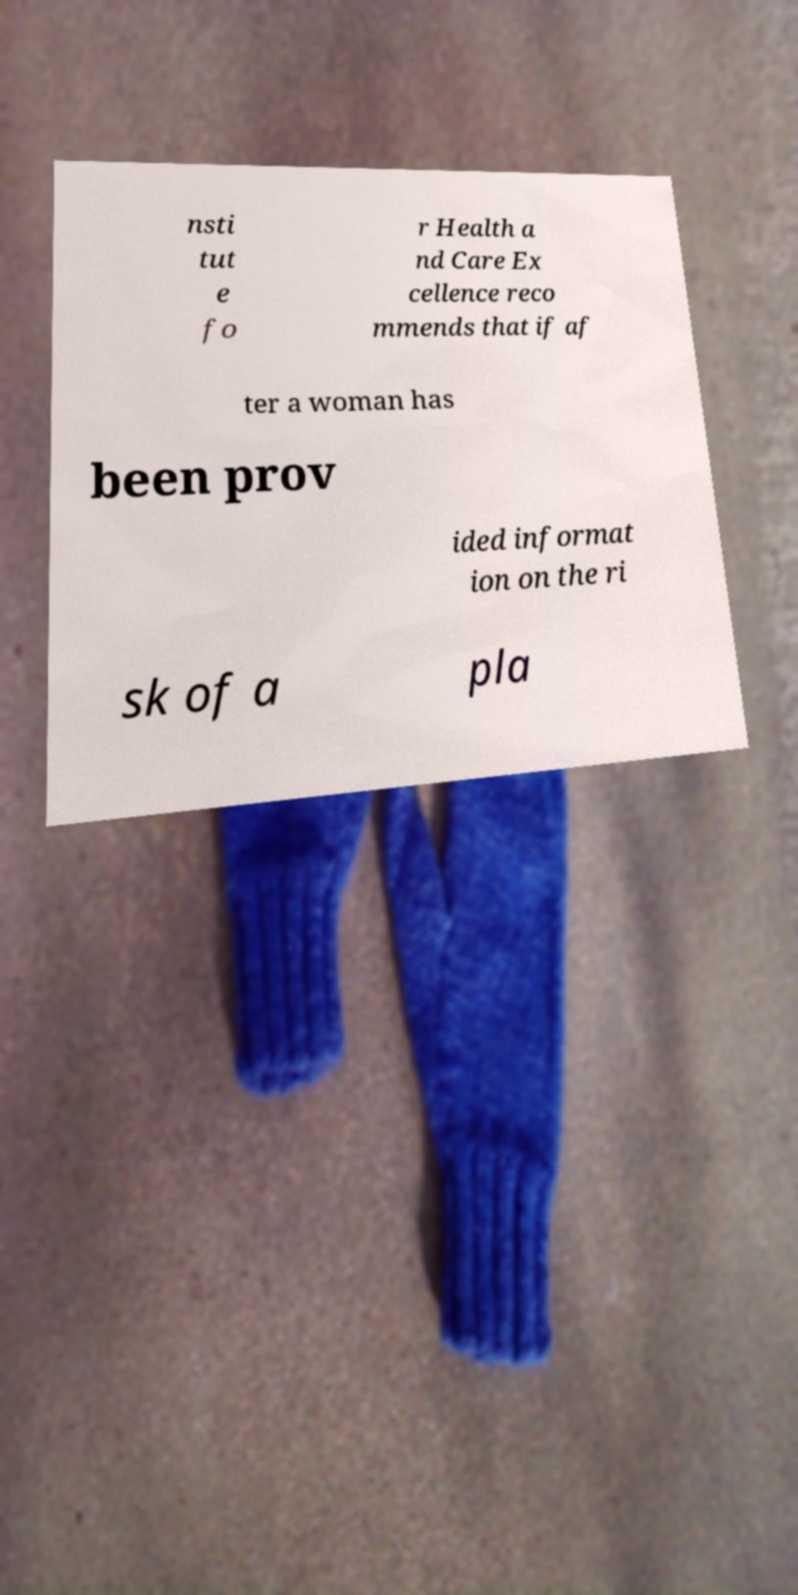What messages or text are displayed in this image? I need them in a readable, typed format. nsti tut e fo r Health a nd Care Ex cellence reco mmends that if af ter a woman has been prov ided informat ion on the ri sk of a pla 